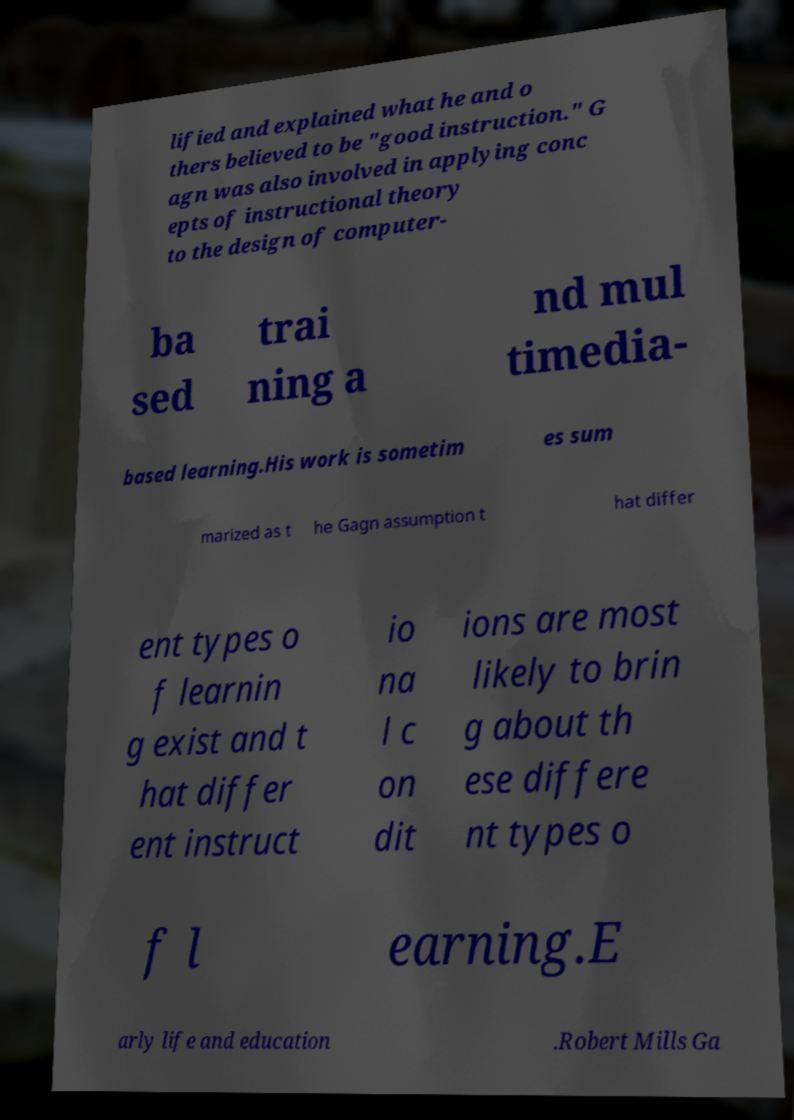Could you assist in decoding the text presented in this image and type it out clearly? lified and explained what he and o thers believed to be "good instruction." G agn was also involved in applying conc epts of instructional theory to the design of computer- ba sed trai ning a nd mul timedia- based learning.His work is sometim es sum marized as t he Gagn assumption t hat differ ent types o f learnin g exist and t hat differ ent instruct io na l c on dit ions are most likely to brin g about th ese differe nt types o f l earning.E arly life and education .Robert Mills Ga 